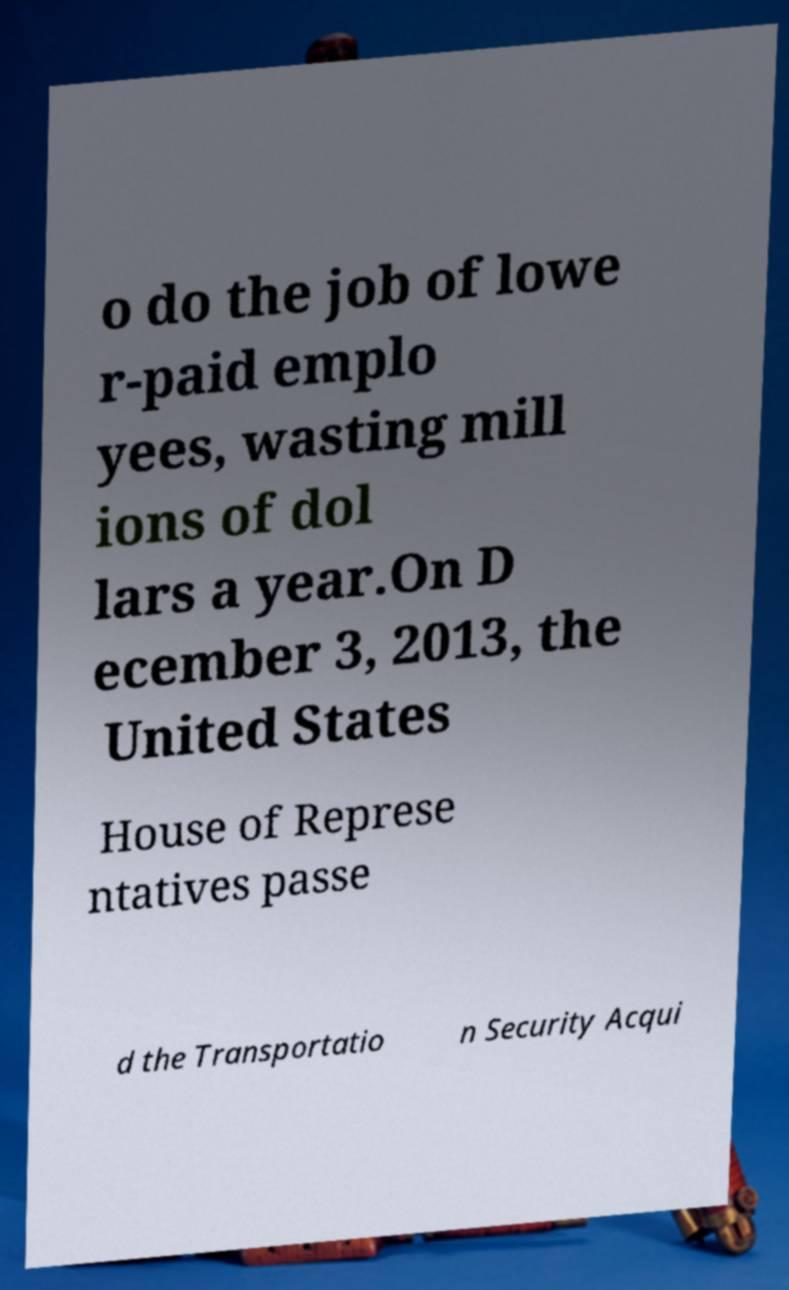What messages or text are displayed in this image? I need them in a readable, typed format. o do the job of lowe r-paid emplo yees, wasting mill ions of dol lars a year.On D ecember 3, 2013, the United States House of Represe ntatives passe d the Transportatio n Security Acqui 